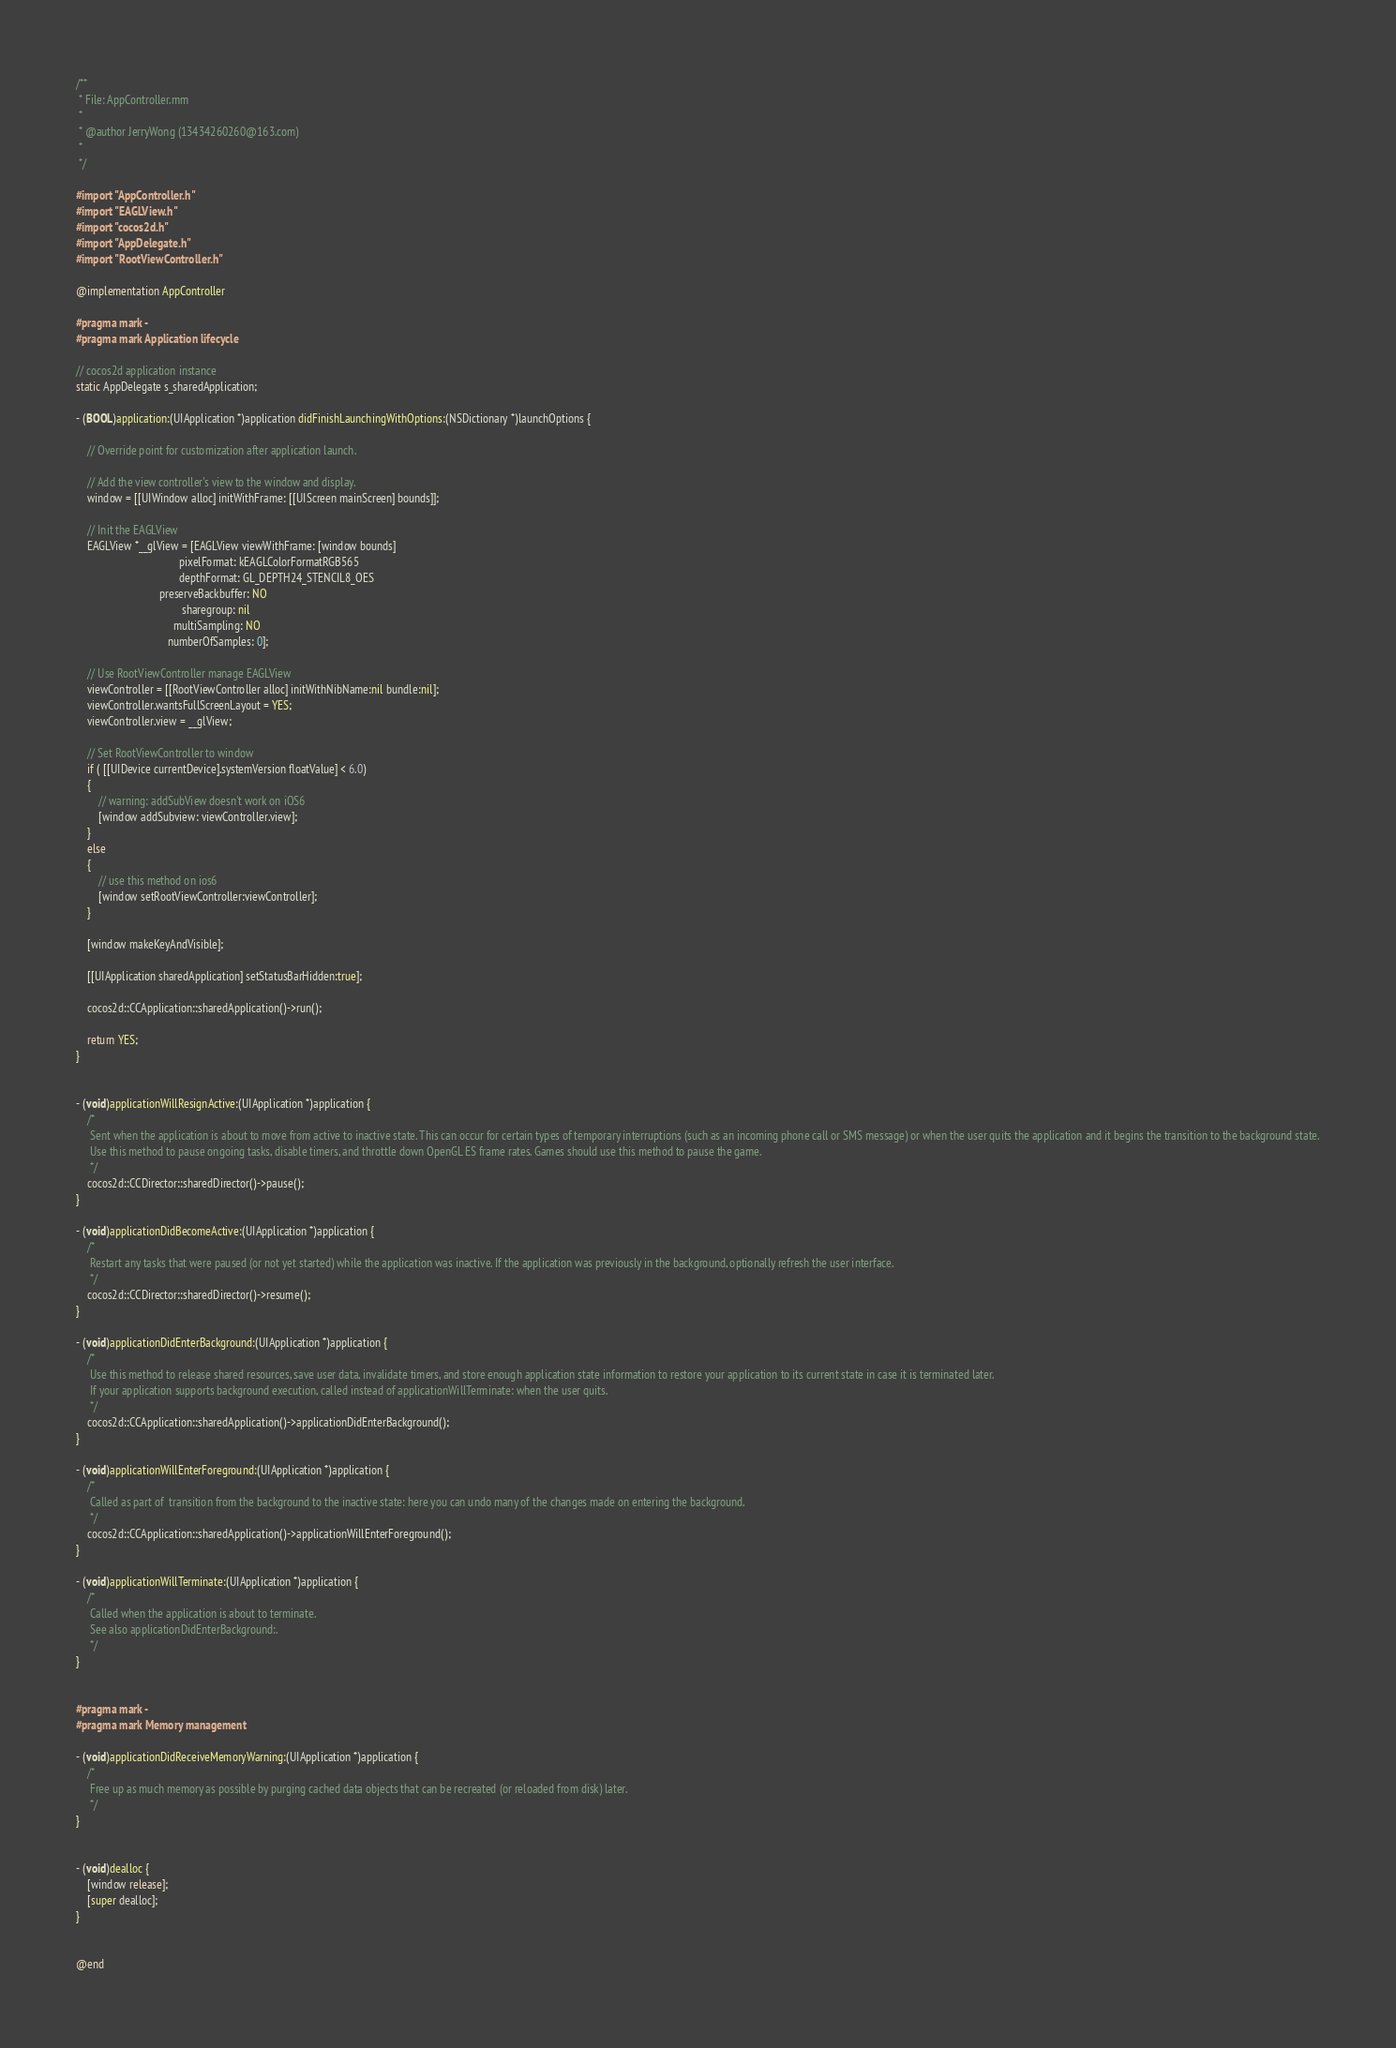<code> <loc_0><loc_0><loc_500><loc_500><_ObjectiveC_>/**
 * File: AppController.mm
 *
 * @author JerryWong (13434260260@163.com)
 *
 */

#import "AppController.h"
#import "EAGLView.h"
#import "cocos2d.h"
#import "AppDelegate.h"
#import "RootViewController.h"

@implementation AppController

#pragma mark -
#pragma mark Application lifecycle

// cocos2d application instance
static AppDelegate s_sharedApplication;

- (BOOL)application:(UIApplication *)application didFinishLaunchingWithOptions:(NSDictionary *)launchOptions {    
    
    // Override point for customization after application launch.

    // Add the view controller's view to the window and display.
    window = [[UIWindow alloc] initWithFrame: [[UIScreen mainScreen] bounds]];
    
    // Init the EAGLView
    EAGLView *__glView = [EAGLView viewWithFrame: [window bounds]
                                     pixelFormat: kEAGLColorFormatRGB565
                                     depthFormat: GL_DEPTH24_STENCIL8_OES
                              preserveBackbuffer: NO
                                      sharegroup: nil
                                   multiSampling: NO
                                 numberOfSamples: 0];

    // Use RootViewController manage EAGLView 
    viewController = [[RootViewController alloc] initWithNibName:nil bundle:nil];
    viewController.wantsFullScreenLayout = YES;
    viewController.view = __glView;

    // Set RootViewController to window
    if ( [[UIDevice currentDevice].systemVersion floatValue] < 6.0)
    {
        // warning: addSubView doesn't work on iOS6
        [window addSubview: viewController.view];
    }
    else
    {
        // use this method on ios6
        [window setRootViewController:viewController];
    }
    
    [window makeKeyAndVisible];
    
    [[UIApplication sharedApplication] setStatusBarHidden:true];
    
    cocos2d::CCApplication::sharedApplication()->run();

    return YES;
}


- (void)applicationWillResignActive:(UIApplication *)application {
    /*
     Sent when the application is about to move from active to inactive state. This can occur for certain types of temporary interruptions (such as an incoming phone call or SMS message) or when the user quits the application and it begins the transition to the background state.
     Use this method to pause ongoing tasks, disable timers, and throttle down OpenGL ES frame rates. Games should use this method to pause the game.
     */
    cocos2d::CCDirector::sharedDirector()->pause();
}

- (void)applicationDidBecomeActive:(UIApplication *)application {
    /*
     Restart any tasks that were paused (or not yet started) while the application was inactive. If the application was previously in the background, optionally refresh the user interface.
     */
    cocos2d::CCDirector::sharedDirector()->resume();
}

- (void)applicationDidEnterBackground:(UIApplication *)application {
    /*
     Use this method to release shared resources, save user data, invalidate timers, and store enough application state information to restore your application to its current state in case it is terminated later. 
     If your application supports background execution, called instead of applicationWillTerminate: when the user quits.
     */
    cocos2d::CCApplication::sharedApplication()->applicationDidEnterBackground();
}

- (void)applicationWillEnterForeground:(UIApplication *)application {
    /*
     Called as part of  transition from the background to the inactive state: here you can undo many of the changes made on entering the background.
     */
    cocos2d::CCApplication::sharedApplication()->applicationWillEnterForeground();
}

- (void)applicationWillTerminate:(UIApplication *)application {
    /*
     Called when the application is about to terminate.
     See also applicationDidEnterBackground:.
     */
}


#pragma mark -
#pragma mark Memory management

- (void)applicationDidReceiveMemoryWarning:(UIApplication *)application {
    /*
     Free up as much memory as possible by purging cached data objects that can be recreated (or reloaded from disk) later.
     */
}


- (void)dealloc {
    [window release];
    [super dealloc];
}


@end
</code> 